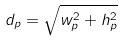Convert formula to latex. <formula><loc_0><loc_0><loc_500><loc_500>d _ { p } = \sqrt { w _ { p } ^ { 2 } + h _ { p } ^ { 2 } }</formula> 